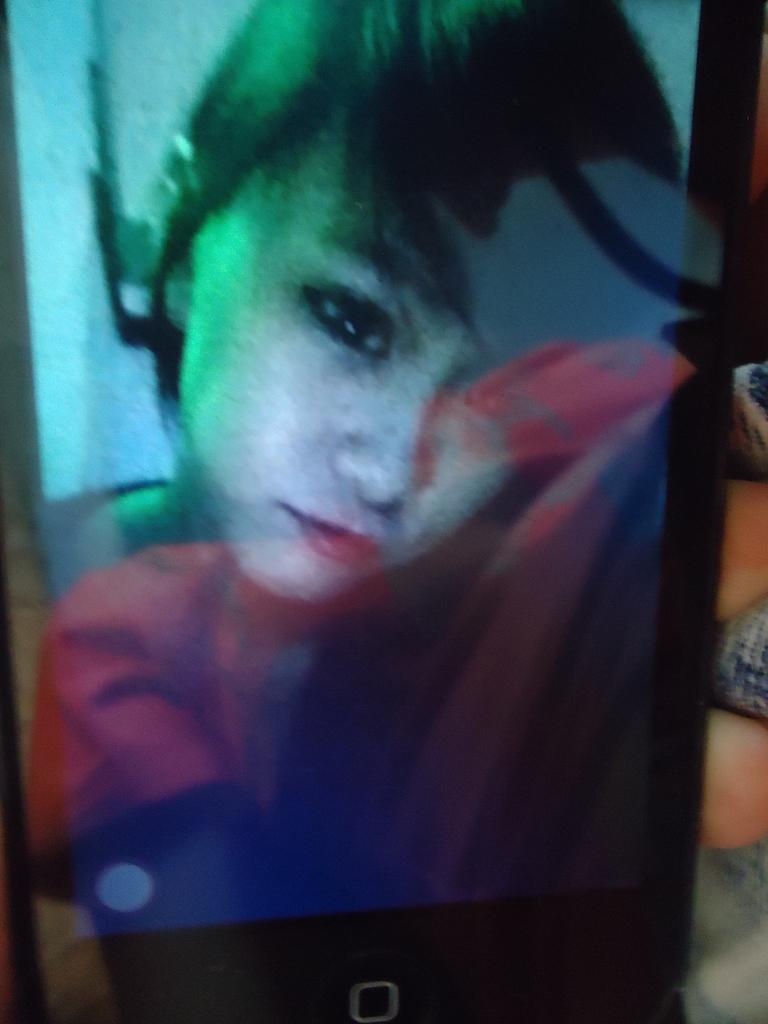What is the main subject of the image? The main subject of the image is a person on a cell phone. What activity is the person engaged in? The person is using a cell phone. What type of mask is the person wearing in the image? There is no mask present in the image; the person is using a cell phone. What is the limit of the person's cell phone usage in the image? The image does not provide information about the person's cell phone usage limit. 